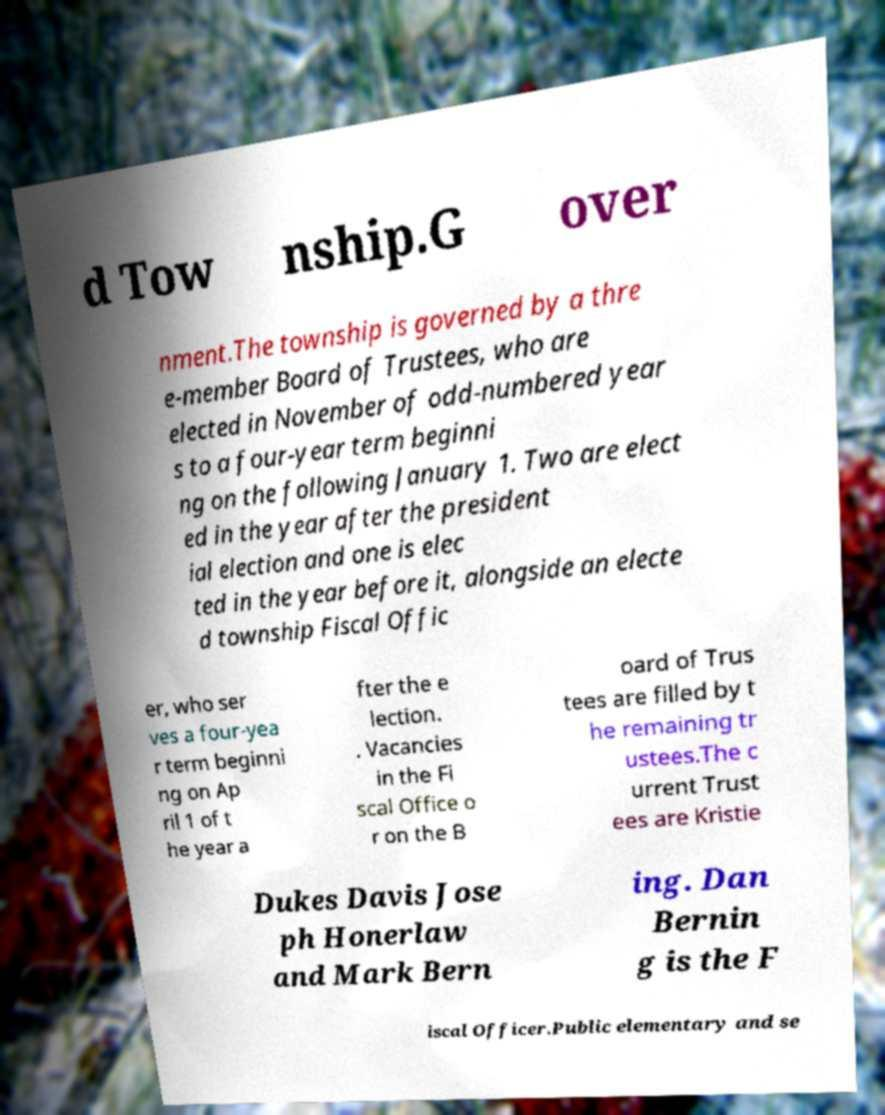I need the written content from this picture converted into text. Can you do that? d Tow nship.G over nment.The township is governed by a thre e-member Board of Trustees, who are elected in November of odd-numbered year s to a four-year term beginni ng on the following January 1. Two are elect ed in the year after the president ial election and one is elec ted in the year before it, alongside an electe d township Fiscal Offic er, who ser ves a four-yea r term beginni ng on Ap ril 1 of t he year a fter the e lection. . Vacancies in the Fi scal Office o r on the B oard of Trus tees are filled by t he remaining tr ustees.The c urrent Trust ees are Kristie Dukes Davis Jose ph Honerlaw and Mark Bern ing. Dan Bernin g is the F iscal Officer.Public elementary and se 